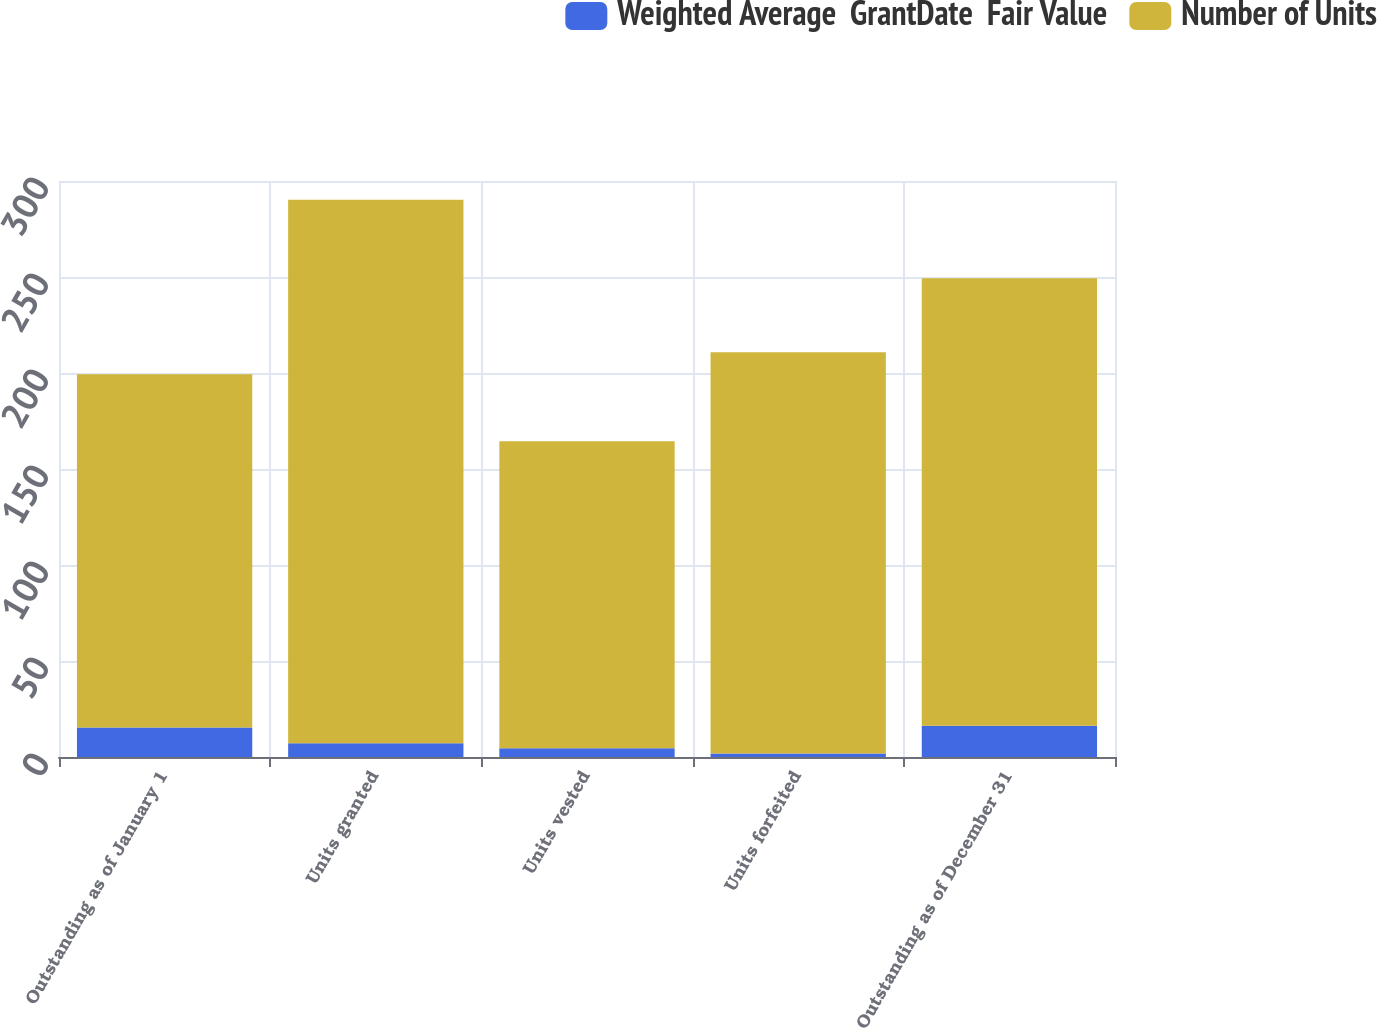<chart> <loc_0><loc_0><loc_500><loc_500><stacked_bar_chart><ecel><fcel>Outstanding as of January 1<fcel>Units granted<fcel>Units vested<fcel>Units forfeited<fcel>Outstanding as of December 31<nl><fcel>Weighted Average  GrantDate  Fair Value<fcel>15.4<fcel>7.2<fcel>4.5<fcel>1.8<fcel>16.3<nl><fcel>Number of Units<fcel>184<fcel>283<fcel>160<fcel>209<fcel>233<nl></chart> 